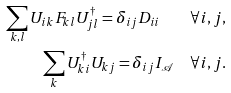Convert formula to latex. <formula><loc_0><loc_0><loc_500><loc_500>\sum _ { k , l } { U _ { i k } F _ { k l } U _ { j l } ^ { \dagger } } = \delta _ { i j } D _ { i i } \quad \forall i , j , \\ \sum _ { k } { U _ { k i } ^ { \dagger } U _ { k j } } = \delta _ { i j } I _ { \mathcal { A } } \quad \forall i , j .</formula> 